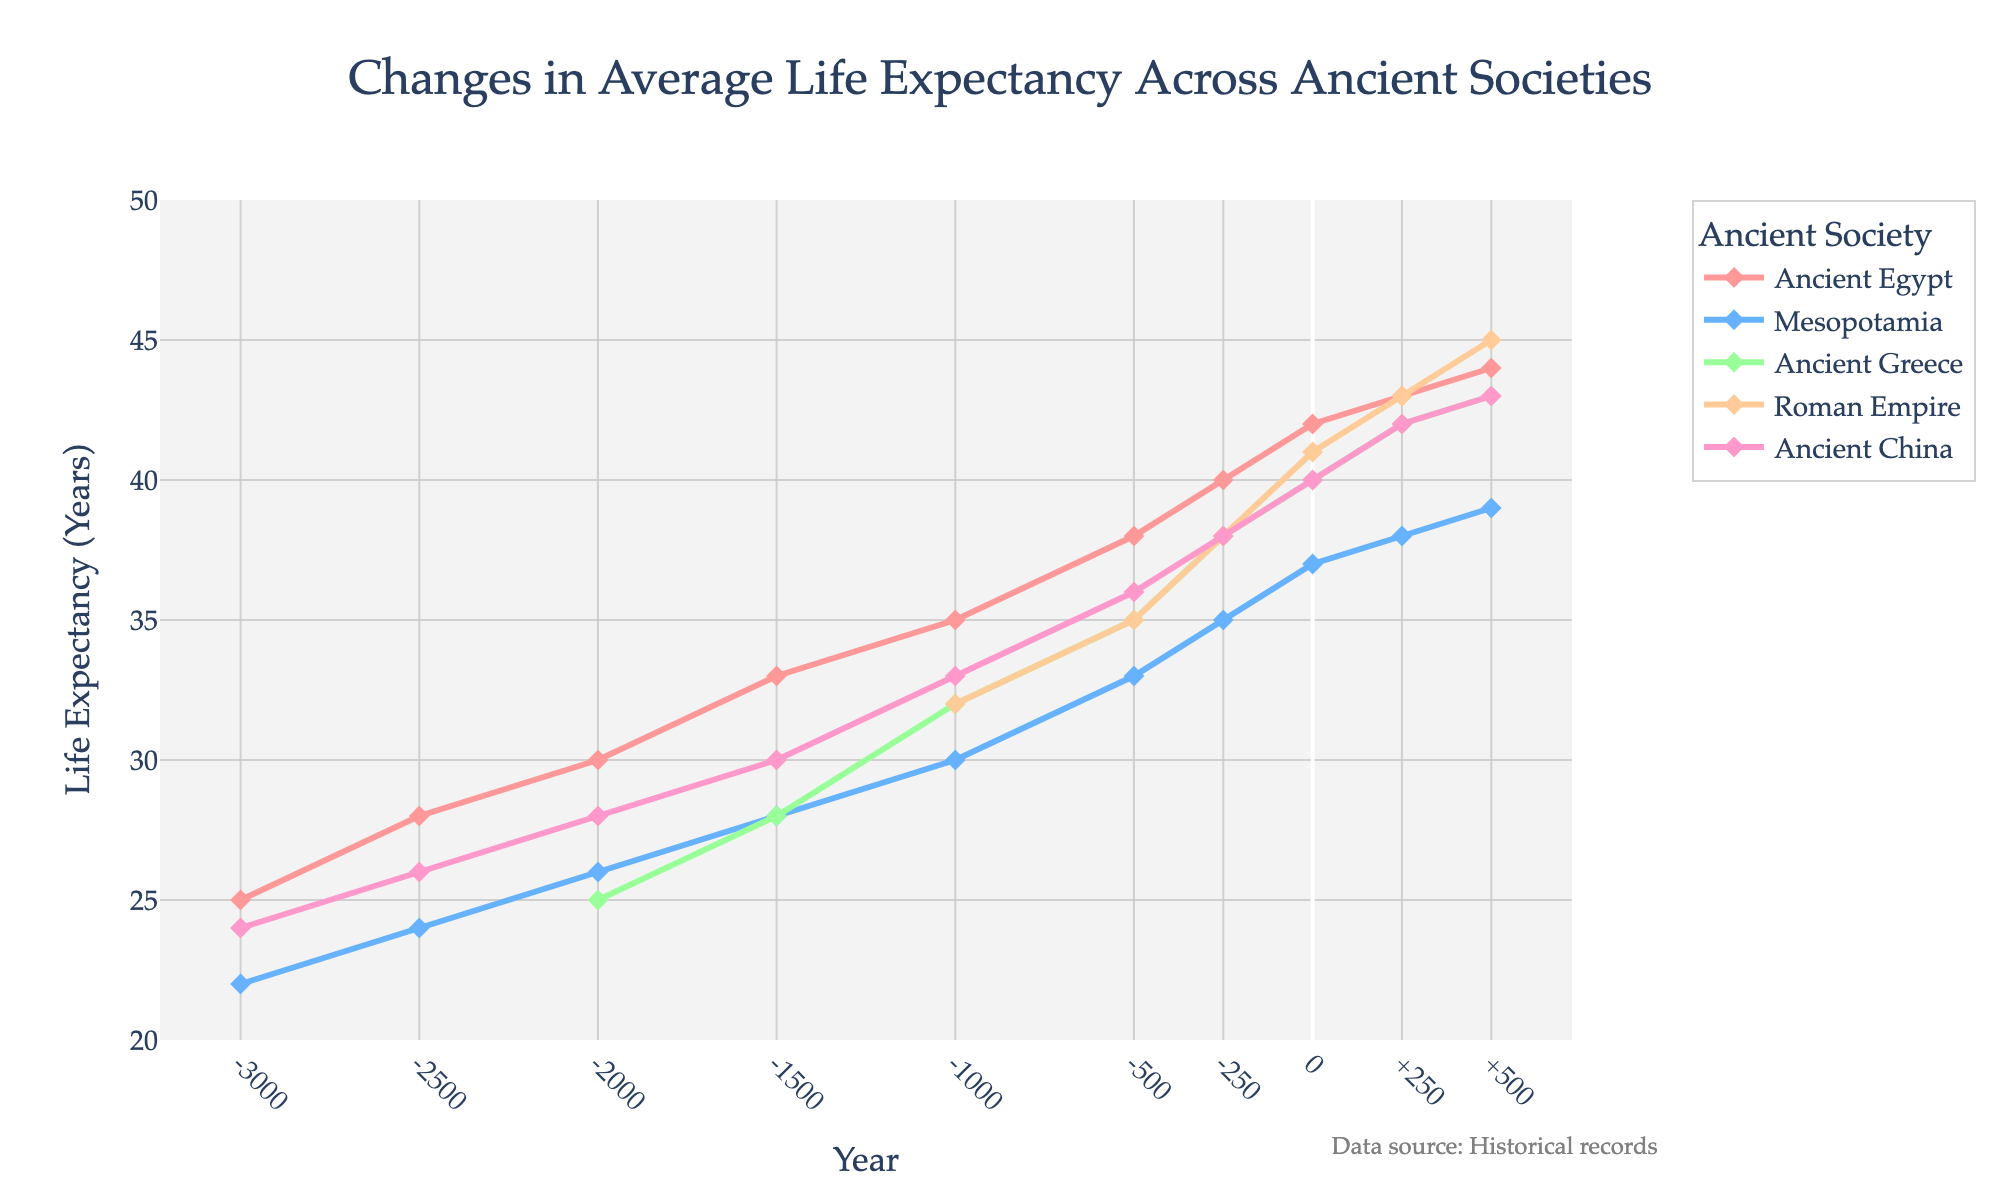Which society had the highest life expectancy in 500 CE? By observing the endpoint in the year 500 CE on the chart, the line representing the Roman Empire peaks the highest compared to other societies.
Answer: Roman Empire What is the overall trend in life expectancy for Ancient China from 3000 BCE to 500 CE? By tracing the line representing Ancient China from 3000 BCE to 500 CE, we observe a consistent upward trend in life expectancy over this period.
Answer: Upward trend How does life expectancy in Ancient Egypt in 3000 BCE compare to that in the Roman Empire in the same period? By looking at the first point in the year 3000 BCE, the data shows Ancient Egypt has a life expectancy of 25 years, while the Roman Empire has no data available for that period.
Answer: No data available for the Roman Empire During which period did Ancient Greece experience the most significant increase in life expectancy? Observing the line for Ancient Greece, the steepest incline appears between -1000 and -500 BCE, with a noticeable jump from 32 to 35 years.
Answer: -1000 to -500 BCE In which year did life expectancy in Mesopotamia surpass 30 years for the first time? By tracking the Mesopotamian line, the life expectancy crosses the 30-year mark for the first time at -1000 BCE.
Answer: -1000 BCE Which society showed the least variability in life expectancy over the observed period? The lines on the chart that are the least steep suggest minimal variability. Mesopotamia shows a relatively stable and gradual increase compared to others.
Answer: Mesopotamia What is the average life expectancy of Ancient Greece and Ancient China in approximately 0 CE? At 0 CE, Ancient Greece had 40 years and Ancient China had 40 years. The average is calculated as (40 + 40) / 2 = 40.
Answer: 40 Compare the change in life expectancy between 250 CE and 500 CE for the Roman Empire and Ancient China. The Roman Empire jumps from 43 to 45 years (an increase of 2 years), while Ancient China goes from 42 to 43 years (an increase of 1 year).
Answer: Roman Empire (2 years) had a higher increase than Ancient China (1 year) Which society's life expectancy reached 35 years first? Observing the chart, Ancient Greece first reached a life expectancy of 35 years around -500 BCE.
Answer: Ancient Greece What is the difference in life expectancy between the highest and the lowest recorded values for Ancient Egypt? The highest value for Ancient Egypt in 500 CE is 44 years, while the lowest in 3000 BCE is 25 years. The difference is calculated as 44 - 25 = 19 years.
Answer: 19 years 